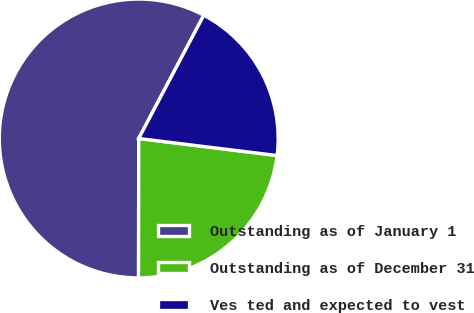Convert chart to OTSL. <chart><loc_0><loc_0><loc_500><loc_500><pie_chart><fcel>Outstanding as of January 1<fcel>Outstanding as of December 31<fcel>Ves ted and expected to vest<nl><fcel>57.71%<fcel>23.07%<fcel>19.22%<nl></chart> 